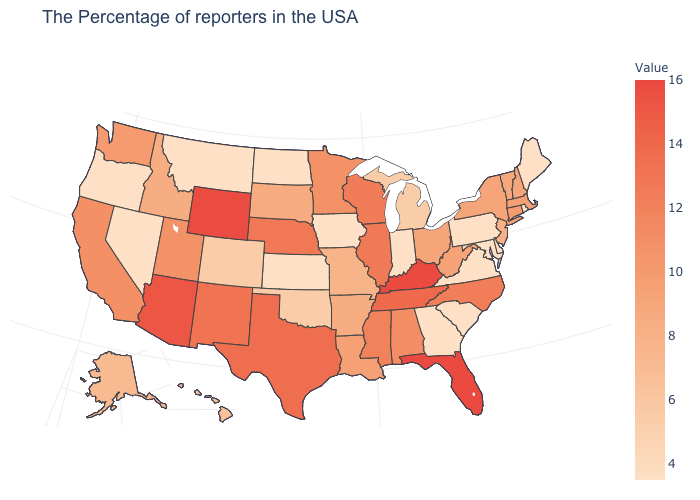Does Oklahoma have a higher value than Delaware?
Concise answer only. Yes. Does Florida have the highest value in the USA?
Concise answer only. Yes. Which states hav the highest value in the South?
Quick response, please. Florida, Kentucky. 